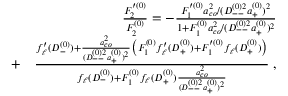Convert formula to latex. <formula><loc_0><loc_0><loc_500><loc_500>\begin{array} { r l r } & { \frac { F _ { 2 } ^ { \prime ( 0 ) } } { F _ { 2 } ^ { ( 0 ) } } = - \frac { F _ { 1 } ^ { \prime ( 0 ) } a _ { c o } ^ { 2 } / ( D _ { - - } ^ { ( 0 ) 2 } a _ { + } ^ { ( 0 ) } ) ^ { 2 } } { 1 + F _ { 1 } ^ { ( 0 ) } a _ { c o } ^ { 2 } / ( D _ { - - } ^ { ( 0 ) 2 } a _ { + } ^ { ( 0 ) } ) ^ { 2 } } } \\ & { + } & { \frac { f _ { \ell } ^ { \prime } ( D _ { - } ^ { ( 0 ) } ) + \frac { a _ { c o } ^ { 2 } } { ( D _ { - - } ^ { ( 0 ) 2 } a _ { + } ^ { ( 0 ) } ) ^ { 2 } } \left ( F _ { 1 } ^ { ( 0 ) } f _ { \ell } ^ { \prime } ( D _ { + } ^ { ( 0 ) } ) + F _ { 1 } ^ { \prime ( 0 ) } f _ { \ell } ( D _ { + } ^ { ( 0 ) } ) \right ) } { f _ { \ell } ( D _ { - } ^ { ( 0 ) } ) + F _ { 1 } ^ { ( 0 ) } f _ { \ell } ( D _ { + } ^ { ( 0 ) } ) \frac { a _ { c o } ^ { 2 } } { ( D _ { - - } ^ { ( 0 ) 2 } a _ { + } ^ { ( 0 ) } ) ^ { 2 } } } \, , } \end{array}</formula> 